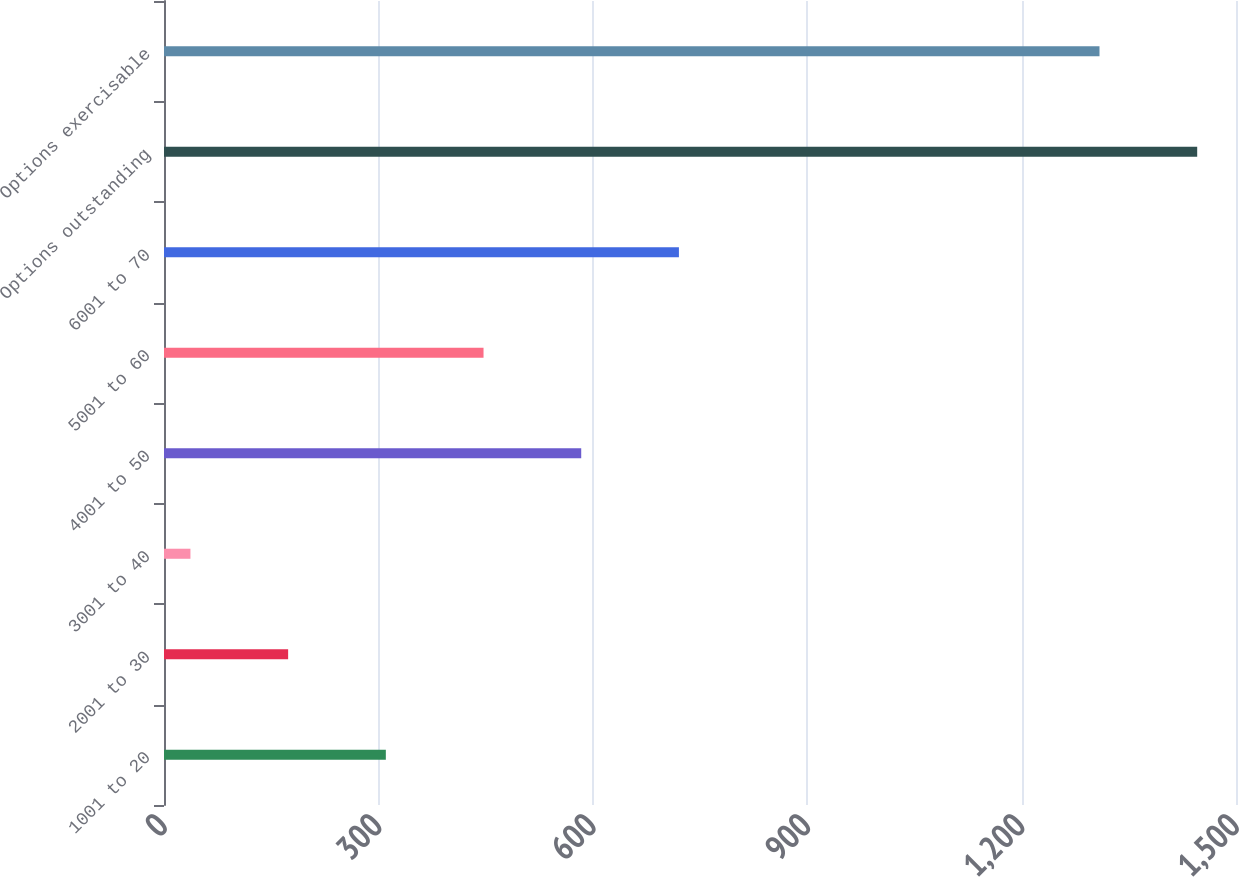Convert chart. <chart><loc_0><loc_0><loc_500><loc_500><bar_chart><fcel>1001 to 20<fcel>2001 to 30<fcel>3001 to 40<fcel>4001 to 50<fcel>5001 to 60<fcel>6001 to 70<fcel>Options outstanding<fcel>Options exercisable<nl><fcel>310.4<fcel>173.7<fcel>37<fcel>583.8<fcel>447.1<fcel>720.5<fcel>1445.7<fcel>1309<nl></chart> 